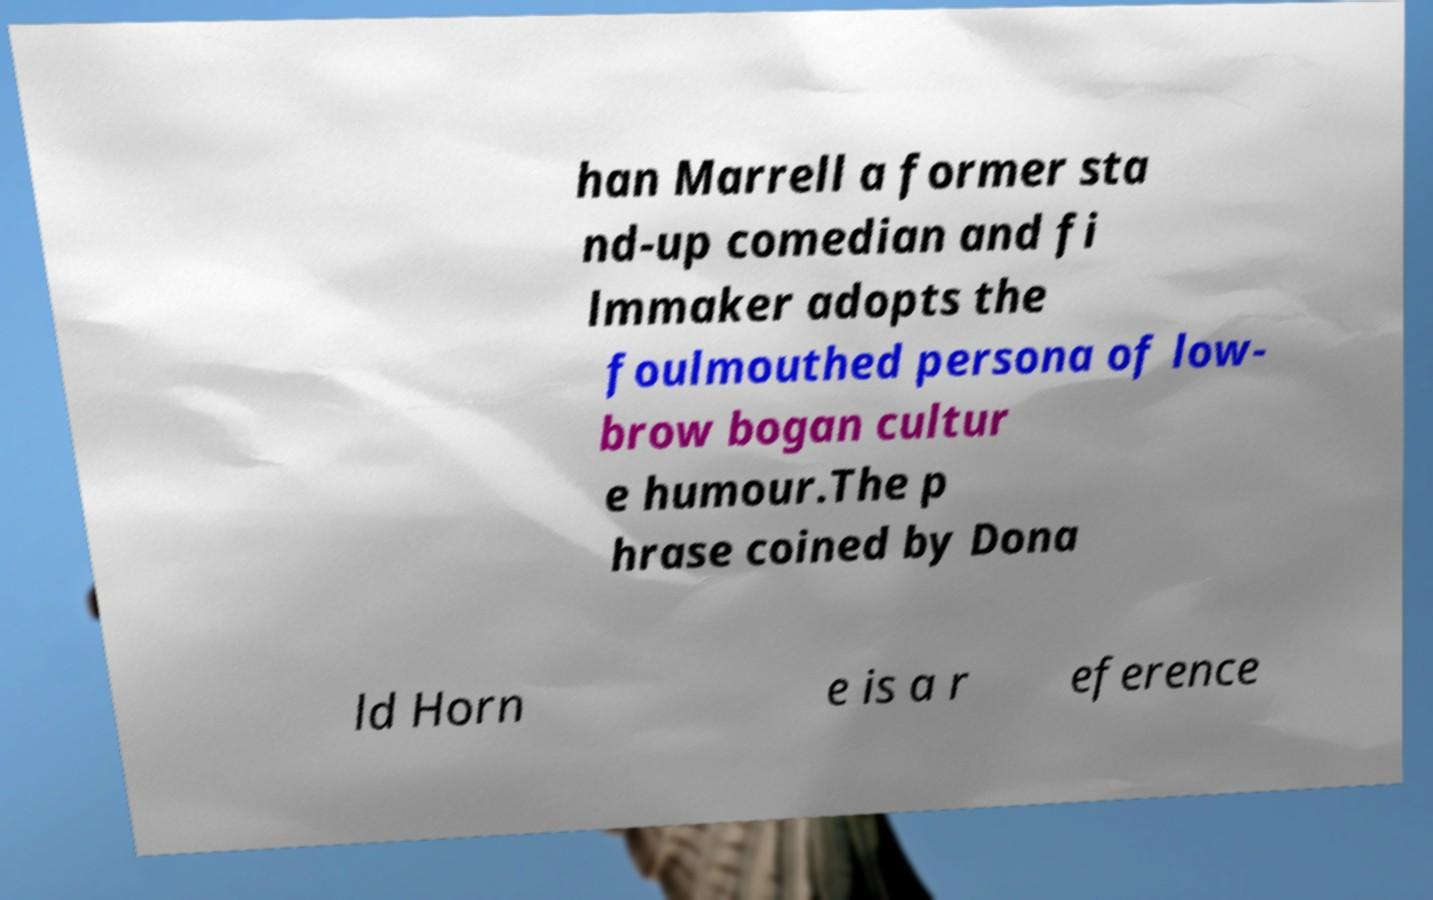Please read and relay the text visible in this image. What does it say? han Marrell a former sta nd-up comedian and fi lmmaker adopts the foulmouthed persona of low- brow bogan cultur e humour.The p hrase coined by Dona ld Horn e is a r eference 